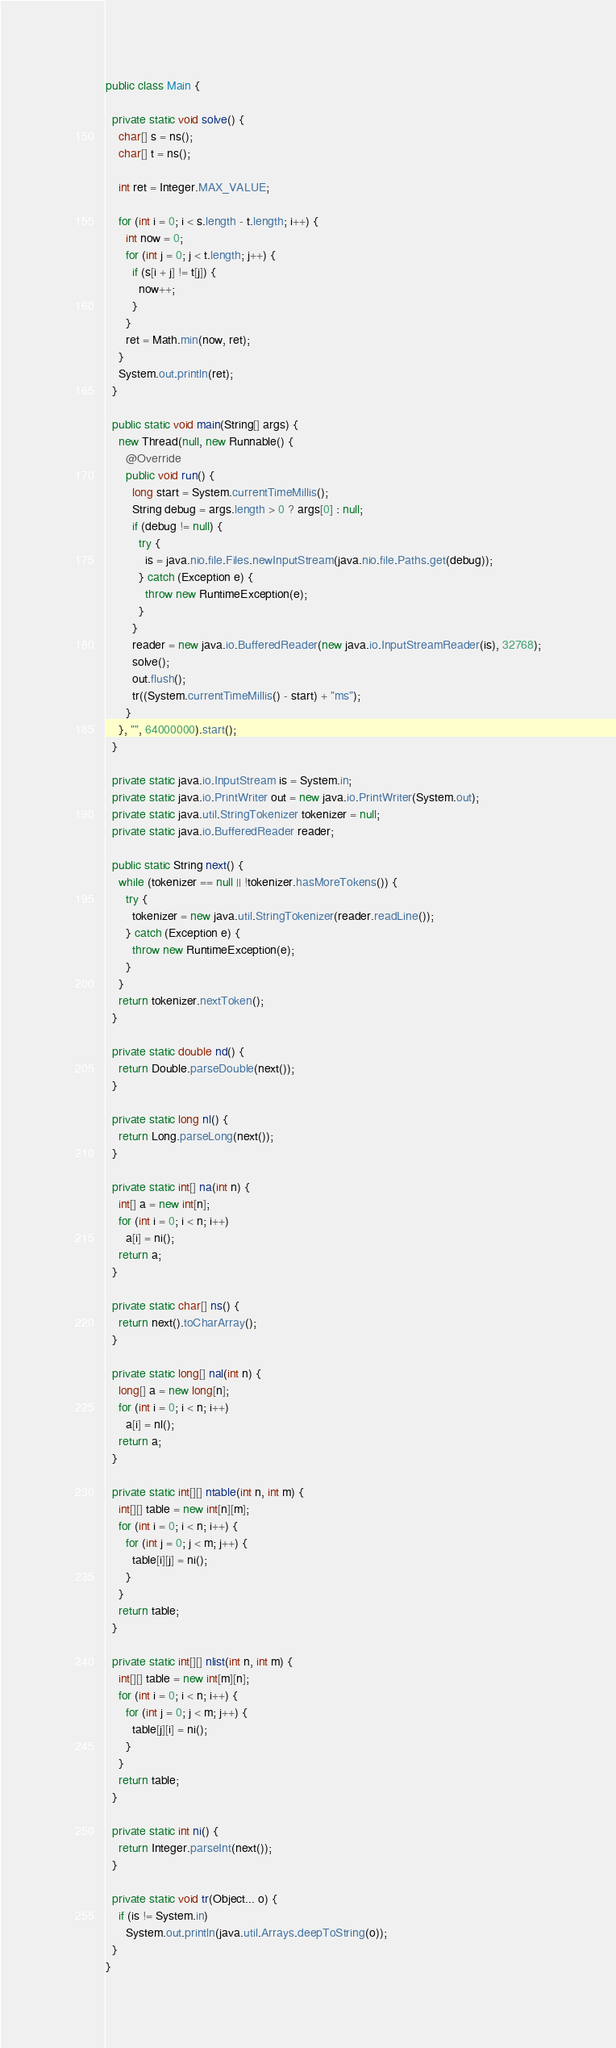<code> <loc_0><loc_0><loc_500><loc_500><_Java_>
public class Main {

  private static void solve() {
    char[] s = ns();
    char[] t = ns();

    int ret = Integer.MAX_VALUE;

    for (int i = 0; i < s.length - t.length; i++) {
      int now = 0;
      for (int j = 0; j < t.length; j++) {
        if (s[i + j] != t[j]) {
          now++;
        }
      }
      ret = Math.min(now, ret);
    }
    System.out.println(ret);
  }

  public static void main(String[] args) {
    new Thread(null, new Runnable() {
      @Override
      public void run() {
        long start = System.currentTimeMillis();
        String debug = args.length > 0 ? args[0] : null;
        if (debug != null) {
          try {
            is = java.nio.file.Files.newInputStream(java.nio.file.Paths.get(debug));
          } catch (Exception e) {
            throw new RuntimeException(e);
          }
        }
        reader = new java.io.BufferedReader(new java.io.InputStreamReader(is), 32768);
        solve();
        out.flush();
        tr((System.currentTimeMillis() - start) + "ms");
      }
    }, "", 64000000).start();
  }

  private static java.io.InputStream is = System.in;
  private static java.io.PrintWriter out = new java.io.PrintWriter(System.out);
  private static java.util.StringTokenizer tokenizer = null;
  private static java.io.BufferedReader reader;

  public static String next() {
    while (tokenizer == null || !tokenizer.hasMoreTokens()) {
      try {
        tokenizer = new java.util.StringTokenizer(reader.readLine());
      } catch (Exception e) {
        throw new RuntimeException(e);
      }
    }
    return tokenizer.nextToken();
  }

  private static double nd() {
    return Double.parseDouble(next());
  }

  private static long nl() {
    return Long.parseLong(next());
  }

  private static int[] na(int n) {
    int[] a = new int[n];
    for (int i = 0; i < n; i++)
      a[i] = ni();
    return a;
  }

  private static char[] ns() {
    return next().toCharArray();
  }

  private static long[] nal(int n) {
    long[] a = new long[n];
    for (int i = 0; i < n; i++)
      a[i] = nl();
    return a;
  }

  private static int[][] ntable(int n, int m) {
    int[][] table = new int[n][m];
    for (int i = 0; i < n; i++) {
      for (int j = 0; j < m; j++) {
        table[i][j] = ni();
      }
    }
    return table;
  }

  private static int[][] nlist(int n, int m) {
    int[][] table = new int[m][n];
    for (int i = 0; i < n; i++) {
      for (int j = 0; j < m; j++) {
        table[j][i] = ni();
      }
    }
    return table;
  }

  private static int ni() {
    return Integer.parseInt(next());
  }

  private static void tr(Object... o) {
    if (is != System.in)
      System.out.println(java.util.Arrays.deepToString(o));
  }
}
</code> 